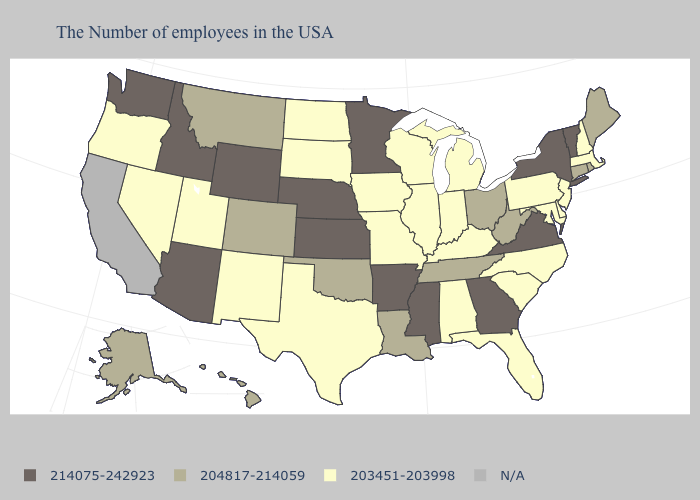Name the states that have a value in the range 204817-214059?
Answer briefly. Maine, Rhode Island, Connecticut, West Virginia, Ohio, Tennessee, Louisiana, Oklahoma, Colorado, Montana, Alaska, Hawaii. Does the map have missing data?
Be succinct. Yes. Among the states that border New Hampshire , does Maine have the highest value?
Be succinct. No. Name the states that have a value in the range 203451-203998?
Keep it brief. Massachusetts, New Hampshire, New Jersey, Delaware, Maryland, Pennsylvania, North Carolina, South Carolina, Florida, Michigan, Kentucky, Indiana, Alabama, Wisconsin, Illinois, Missouri, Iowa, Texas, South Dakota, North Dakota, New Mexico, Utah, Nevada, Oregon. Which states have the lowest value in the USA?
Write a very short answer. Massachusetts, New Hampshire, New Jersey, Delaware, Maryland, Pennsylvania, North Carolina, South Carolina, Florida, Michigan, Kentucky, Indiana, Alabama, Wisconsin, Illinois, Missouri, Iowa, Texas, South Dakota, North Dakota, New Mexico, Utah, Nevada, Oregon. What is the value of Illinois?
Concise answer only. 203451-203998. What is the lowest value in the USA?
Keep it brief. 203451-203998. How many symbols are there in the legend?
Be succinct. 4. Among the states that border California , which have the lowest value?
Be succinct. Nevada, Oregon. What is the highest value in the USA?
Quick response, please. 214075-242923. What is the highest value in states that border Maine?
Short answer required. 203451-203998. Name the states that have a value in the range 214075-242923?
Be succinct. Vermont, New York, Virginia, Georgia, Mississippi, Arkansas, Minnesota, Kansas, Nebraska, Wyoming, Arizona, Idaho, Washington. Name the states that have a value in the range N/A?
Give a very brief answer. California. 